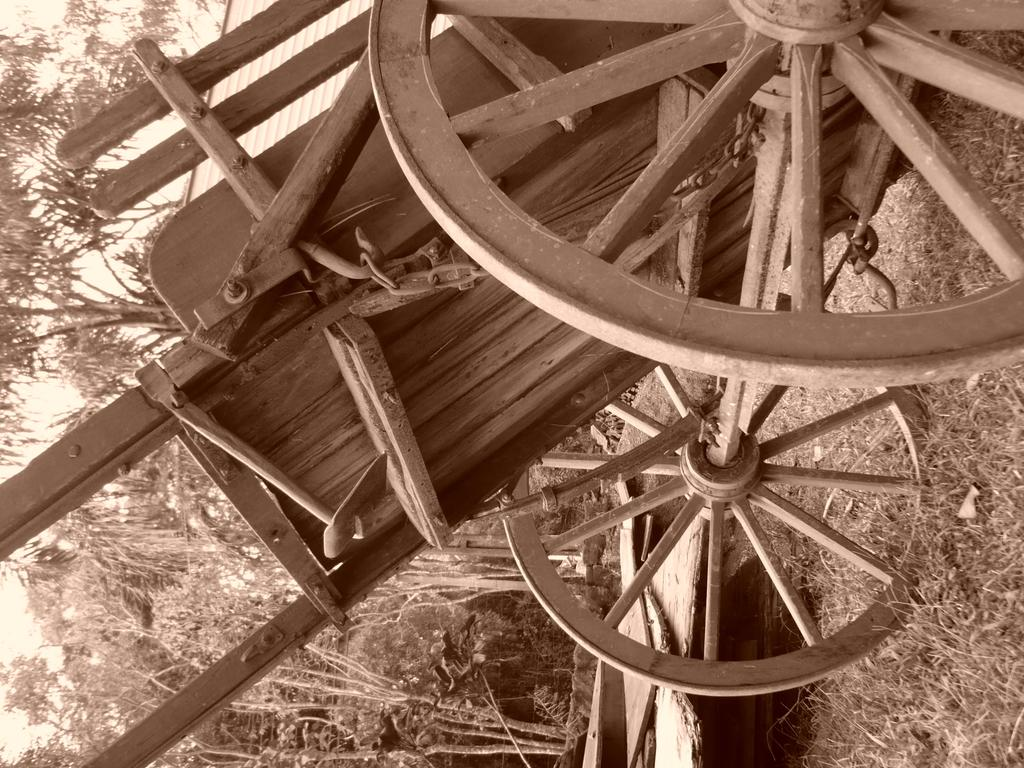What is the main subject of the picture? The main subject of the picture is a bull cart. What material is the bull cart made of? The bull cart is made of wood. What type of surface is visible on the floor? There is grass on the floor. What can be seen in the background of the picture? There are trees in the picture. How would you describe the sky in the image? The sky is clear in the image. What type of theory is being discussed by the bull cart in the image? There is no indication in the image that the bull cart is discussing any theories. Can you see any quills in the image? There are no quills present in the image. 